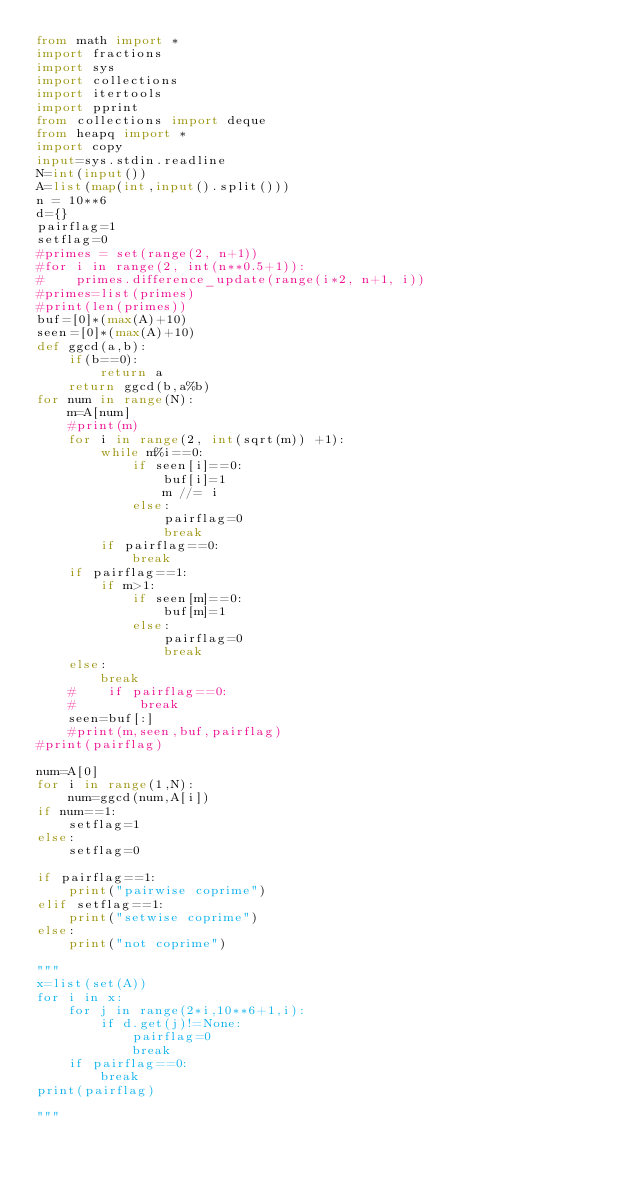<code> <loc_0><loc_0><loc_500><loc_500><_Python_>from math import *
import fractions
import sys
import collections
import itertools
import pprint
from collections import deque
from heapq import *
import copy
input=sys.stdin.readline
N=int(input())
A=list(map(int,input().split()))
n = 10**6
d={}
pairflag=1
setflag=0
#primes = set(range(2, n+1))
#for i in range(2, int(n**0.5+1)):
#    primes.difference_update(range(i*2, n+1, i))
#primes=list(primes)
#print(len(primes))
buf=[0]*(max(A)+10)
seen=[0]*(max(A)+10)
def ggcd(a,b):
    if(b==0):
        return a
    return ggcd(b,a%b)
for num in range(N):
    m=A[num]
    #print(m)
    for i in range(2, int(sqrt(m)) +1):
        while m%i==0:
            if seen[i]==0:
                buf[i]=1
                m //= i
            else:
                pairflag=0
                break
        if pairflag==0:
            break
    if pairflag==1:
        if m>1:
            if seen[m]==0:
                buf[m]=1
            else:
                pairflag=0
                break
    else:
        break
    #    if pairflag==0:
    #        break
    seen=buf[:]
    #print(m,seen,buf,pairflag)
#print(pairflag)

num=A[0]
for i in range(1,N):
    num=ggcd(num,A[i])
if num==1:
    setflag=1
else:
    setflag=0

if pairflag==1:
    print("pairwise coprime")
elif setflag==1:
    print("setwise coprime")
else:
    print("not coprime")

"""
x=list(set(A))
for i in x:
    for j in range(2*i,10**6+1,i):
        if d.get(j)!=None:
            pairflag=0
            break
    if pairflag==0:
        break
print(pairflag)

"""</code> 